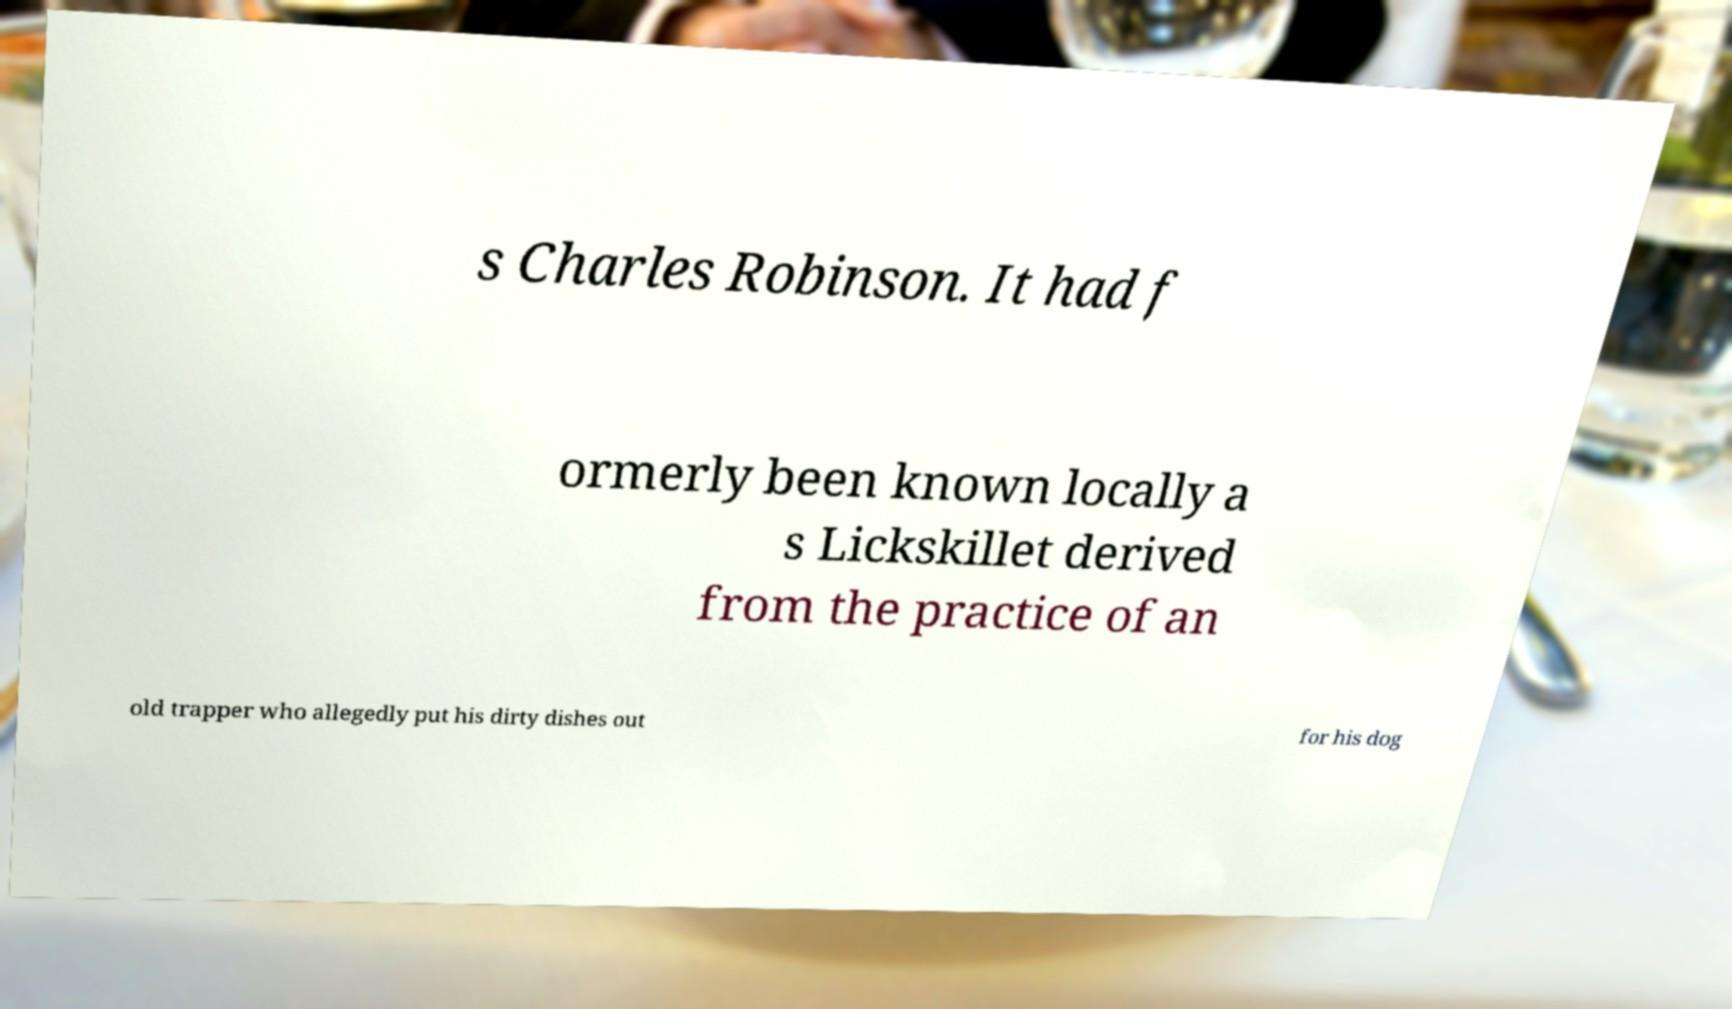Can you read and provide the text displayed in the image?This photo seems to have some interesting text. Can you extract and type it out for me? s Charles Robinson. It had f ormerly been known locally a s Lickskillet derived from the practice of an old trapper who allegedly put his dirty dishes out for his dog 